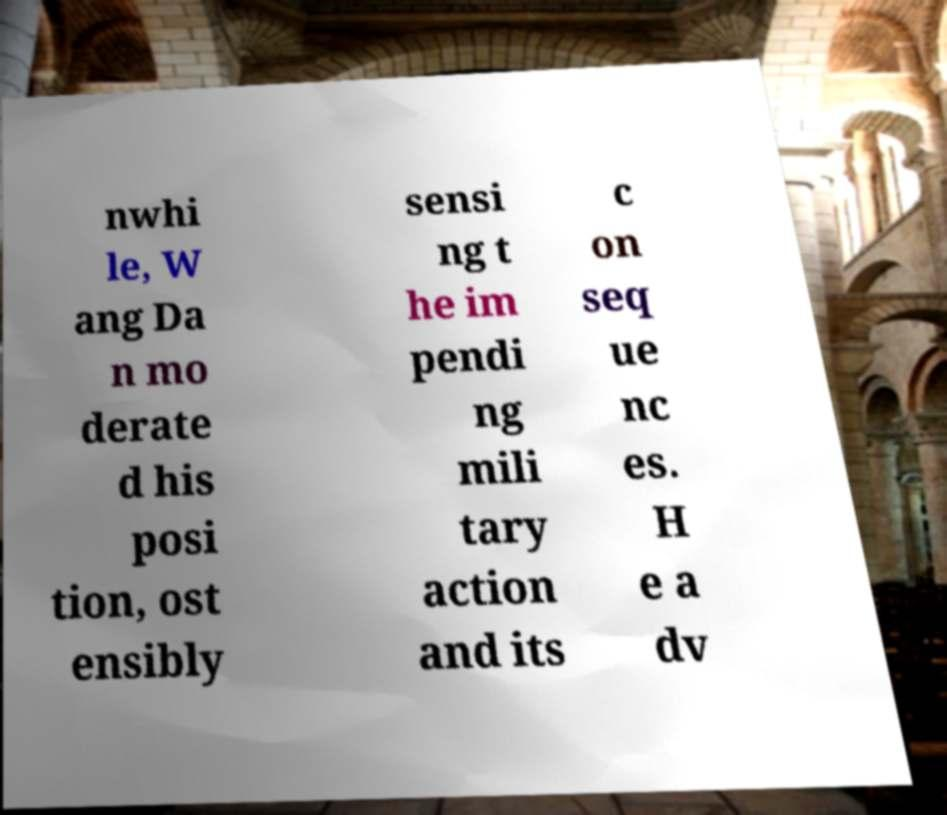Please read and relay the text visible in this image. What does it say? nwhi le, W ang Da n mo derate d his posi tion, ost ensibly sensi ng t he im pendi ng mili tary action and its c on seq ue nc es. H e a dv 